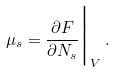<formula> <loc_0><loc_0><loc_500><loc_500>\mu _ { s } = \frac { \partial F } { \partial N _ { s } } \Big | _ { V } \, .</formula> 